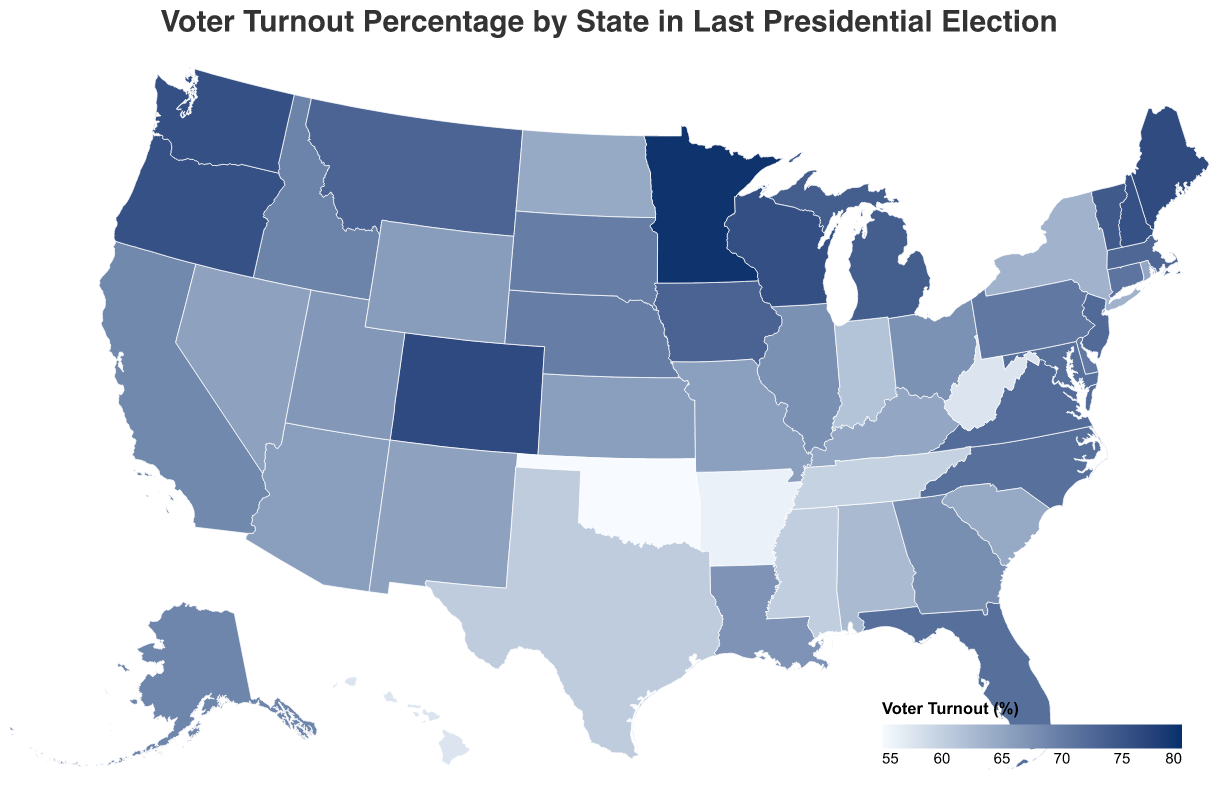What is the title of the figure? The title can be found at the top of the figure, typically in larger or bold font for emphasis. In this case, the figure is labeled "Voter Turnout Percentage by State in Last Presidential Election."
Answer: Voter Turnout Percentage by State in Last Presidential Election Which state has the highest voter turnout percentage, and what is that percentage? Identifying the state with the highest voter turnout involves scanning the colors on the map and also using the legend. Minnesota has the highest voter turnout percentage, indicated by the darkest color on the map.
Answer: Minnesota, 79.6% Which state has the lowest voter turnout percentage, and what is that percentage? By inspecting the colors on the map and referring to the legend, it's clear that Oklahoma has the lowest voter turnout percentage, indicated by the lightest color.
Answer: Oklahoma, 55.0% What is the difference in voter turnout percentage between the state with the highest turnout and the state with the lowest turnout? First, find the highest percentage (Minnesota, 79.6%) and the lowest percentage (Oklahoma, 55.0%). Subtract the lowest percentage from the highest to get the difference. 79.6% - 55.0% = 24.6%
Answer: 24.6% How many states have a voter turnout percentage above 70%? By examining the color scale and the corresponding states' colors, we can count the number of states with a color that represents a turnout above 70%. The figure shows the states clearly with their respective colors, which match the higher percentages. A count reveals there are 18 such states.
Answer: 18 Which states have a voter turnout percentage between 65% and 70%? By cross-referencing the color shades within the 65%-70% range on the map, we can list the states that fall into this range: Alaska, Arizona, Illinois, Kansas, Missouri, Georgia, Utah, and Louisiana.
Answer: Alaska, Arizona, Illinois, Kansas, Missouri, Georgia, Utah, Louisiana What is the average voter turnout percentage for all states shown in the figure? To calculate the average, add up all the voter turnout percentages and divide by the number of states. Total = 2987.5%, number of states = 50. Average = 2987.5 / 50 = 59.75%.
Answer: 59.75% How does the voter turnout in California compare to that in Texas? Check both states on the map or the provided data. California has a voter turnout of 68.5%, while Texas has a turnout of 60.4%. California's voter turnout is higher than Texas's by 8.1%.
Answer: California is higher by 8.1% Which regions of the United States appear to have the highest voter turnout percentages based on the color scale? Observing the color distribution across the map, the northern Midwest and parts of New England show darker shades, indicating higher voter turnout percentages. These include states like Minnesota, Wisconsin, and New Hampshire.
Answer: Northern Midwest and New England Is there a pattern in voter turnout related to geographic location? By comparing the colors and corresponding voter turnout percentages across the different regions, one can see higher percentages often in northern states and lower in some southern states, suggesting a potential geographic trend.
Answer: Northern states generally have higher turnout than southern states 